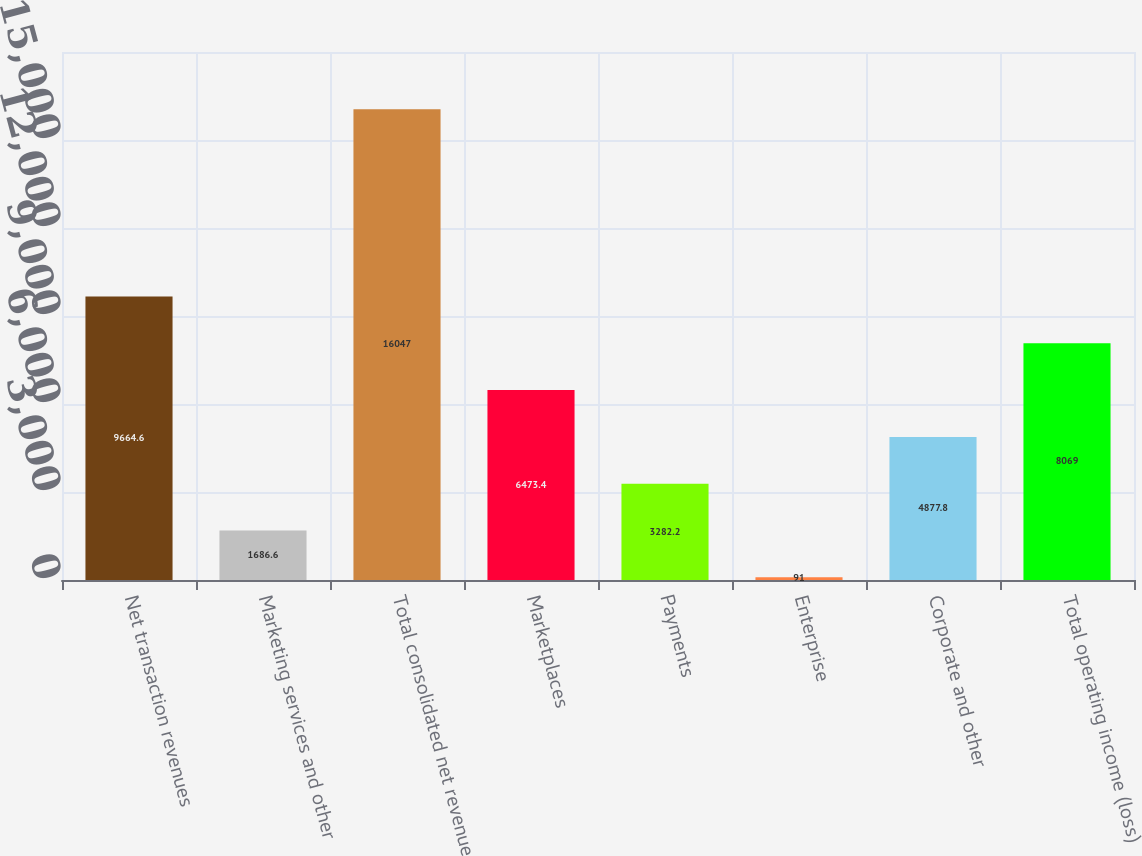<chart> <loc_0><loc_0><loc_500><loc_500><bar_chart><fcel>Net transaction revenues<fcel>Marketing services and other<fcel>Total consolidated net revenue<fcel>Marketplaces<fcel>Payments<fcel>Enterprise<fcel>Corporate and other<fcel>Total operating income (loss)<nl><fcel>9664.6<fcel>1686.6<fcel>16047<fcel>6473.4<fcel>3282.2<fcel>91<fcel>4877.8<fcel>8069<nl></chart> 